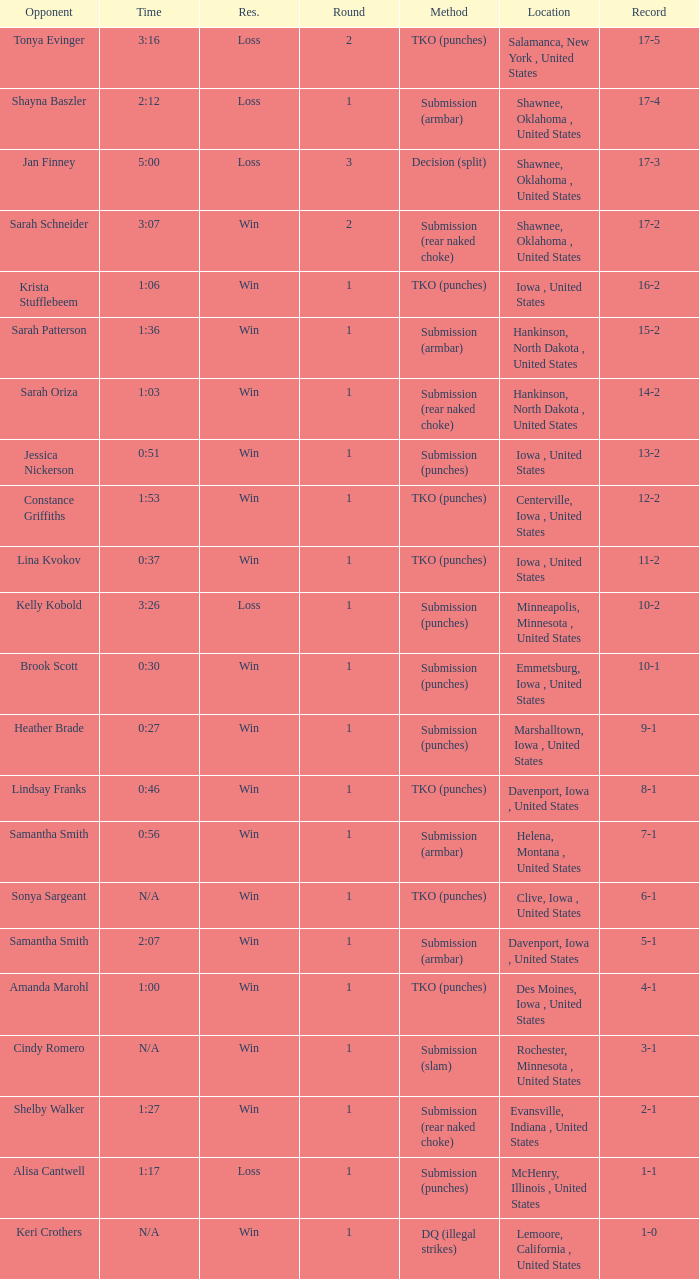What is the highest number of rounds for a 3:16 fight? 2.0. 